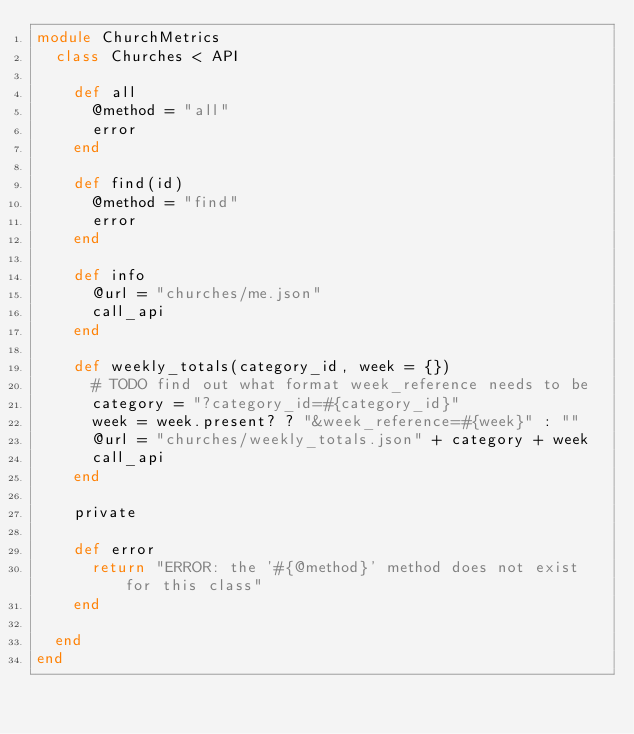<code> <loc_0><loc_0><loc_500><loc_500><_Ruby_>module ChurchMetrics
  class Churches < API

    def all
      @method = "all"
      error
    end

    def find(id)
      @method = "find"
      error
    end

    def info
      @url = "churches/me.json"
      call_api
    end

    def weekly_totals(category_id, week = {})
      # TODO find out what format week_reference needs to be
      category = "?category_id=#{category_id}"
      week = week.present? ? "&week_reference=#{week}" : ""
      @url = "churches/weekly_totals.json" + category + week
      call_api
    end

    private

    def error
      return "ERROR: the '#{@method}' method does not exist for this class"
    end

  end
end
</code> 